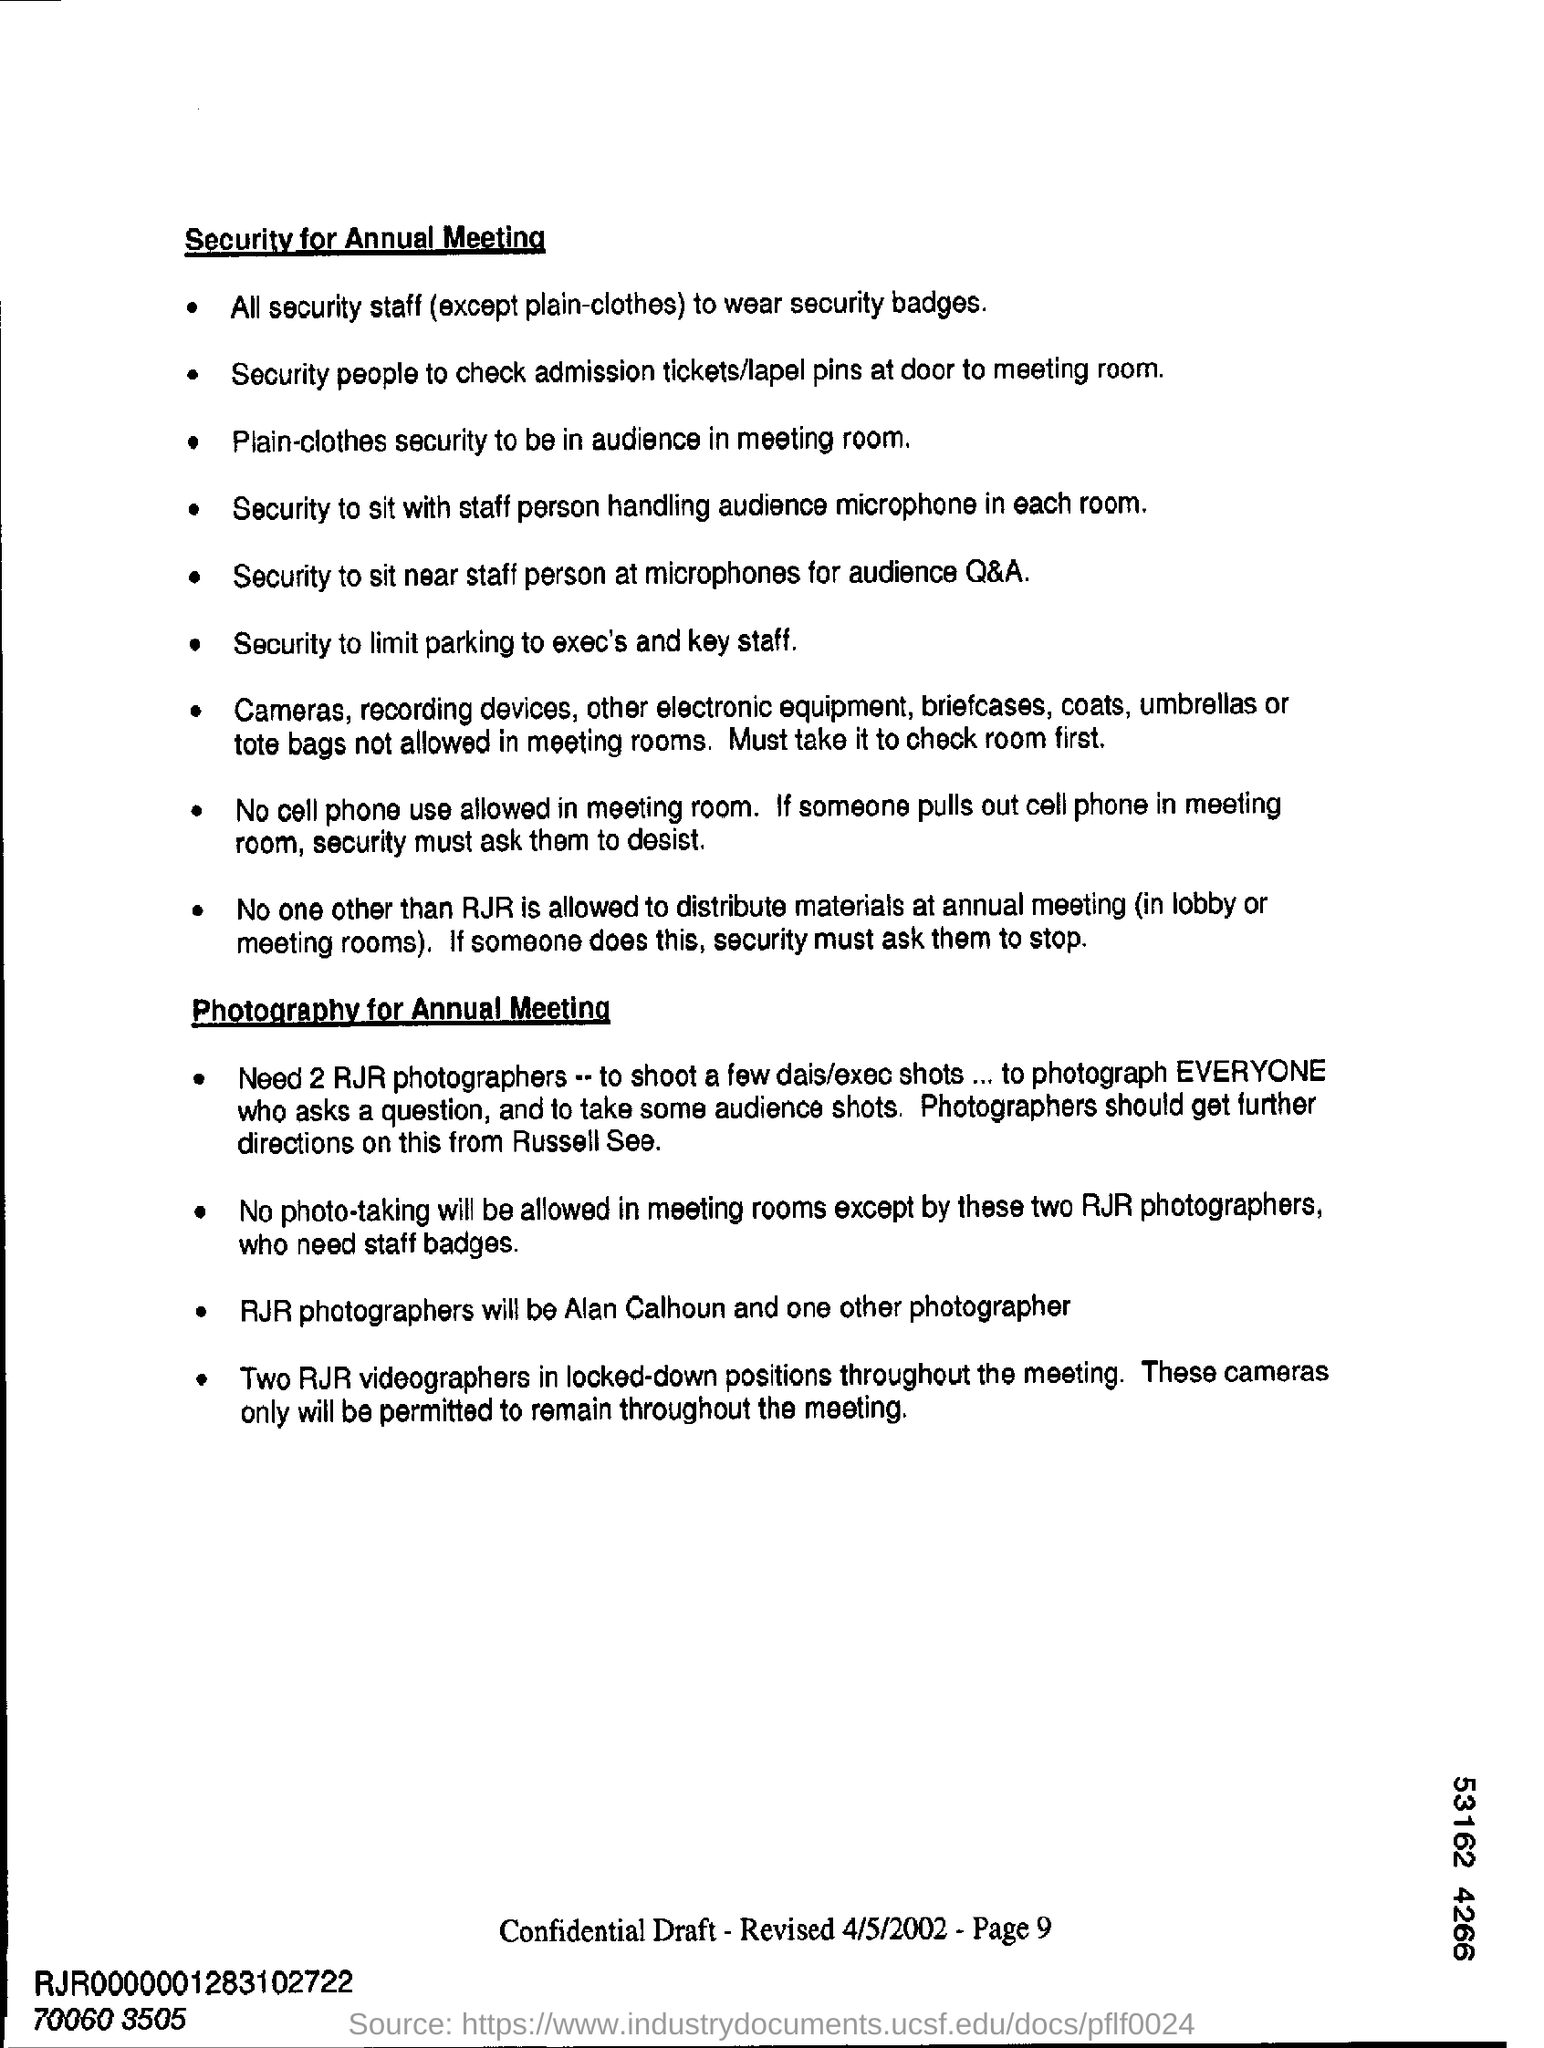List a handful of essential elements in this visual. Two RJR photographers are necessary. It is important to include page numbers in the footer of each page. 